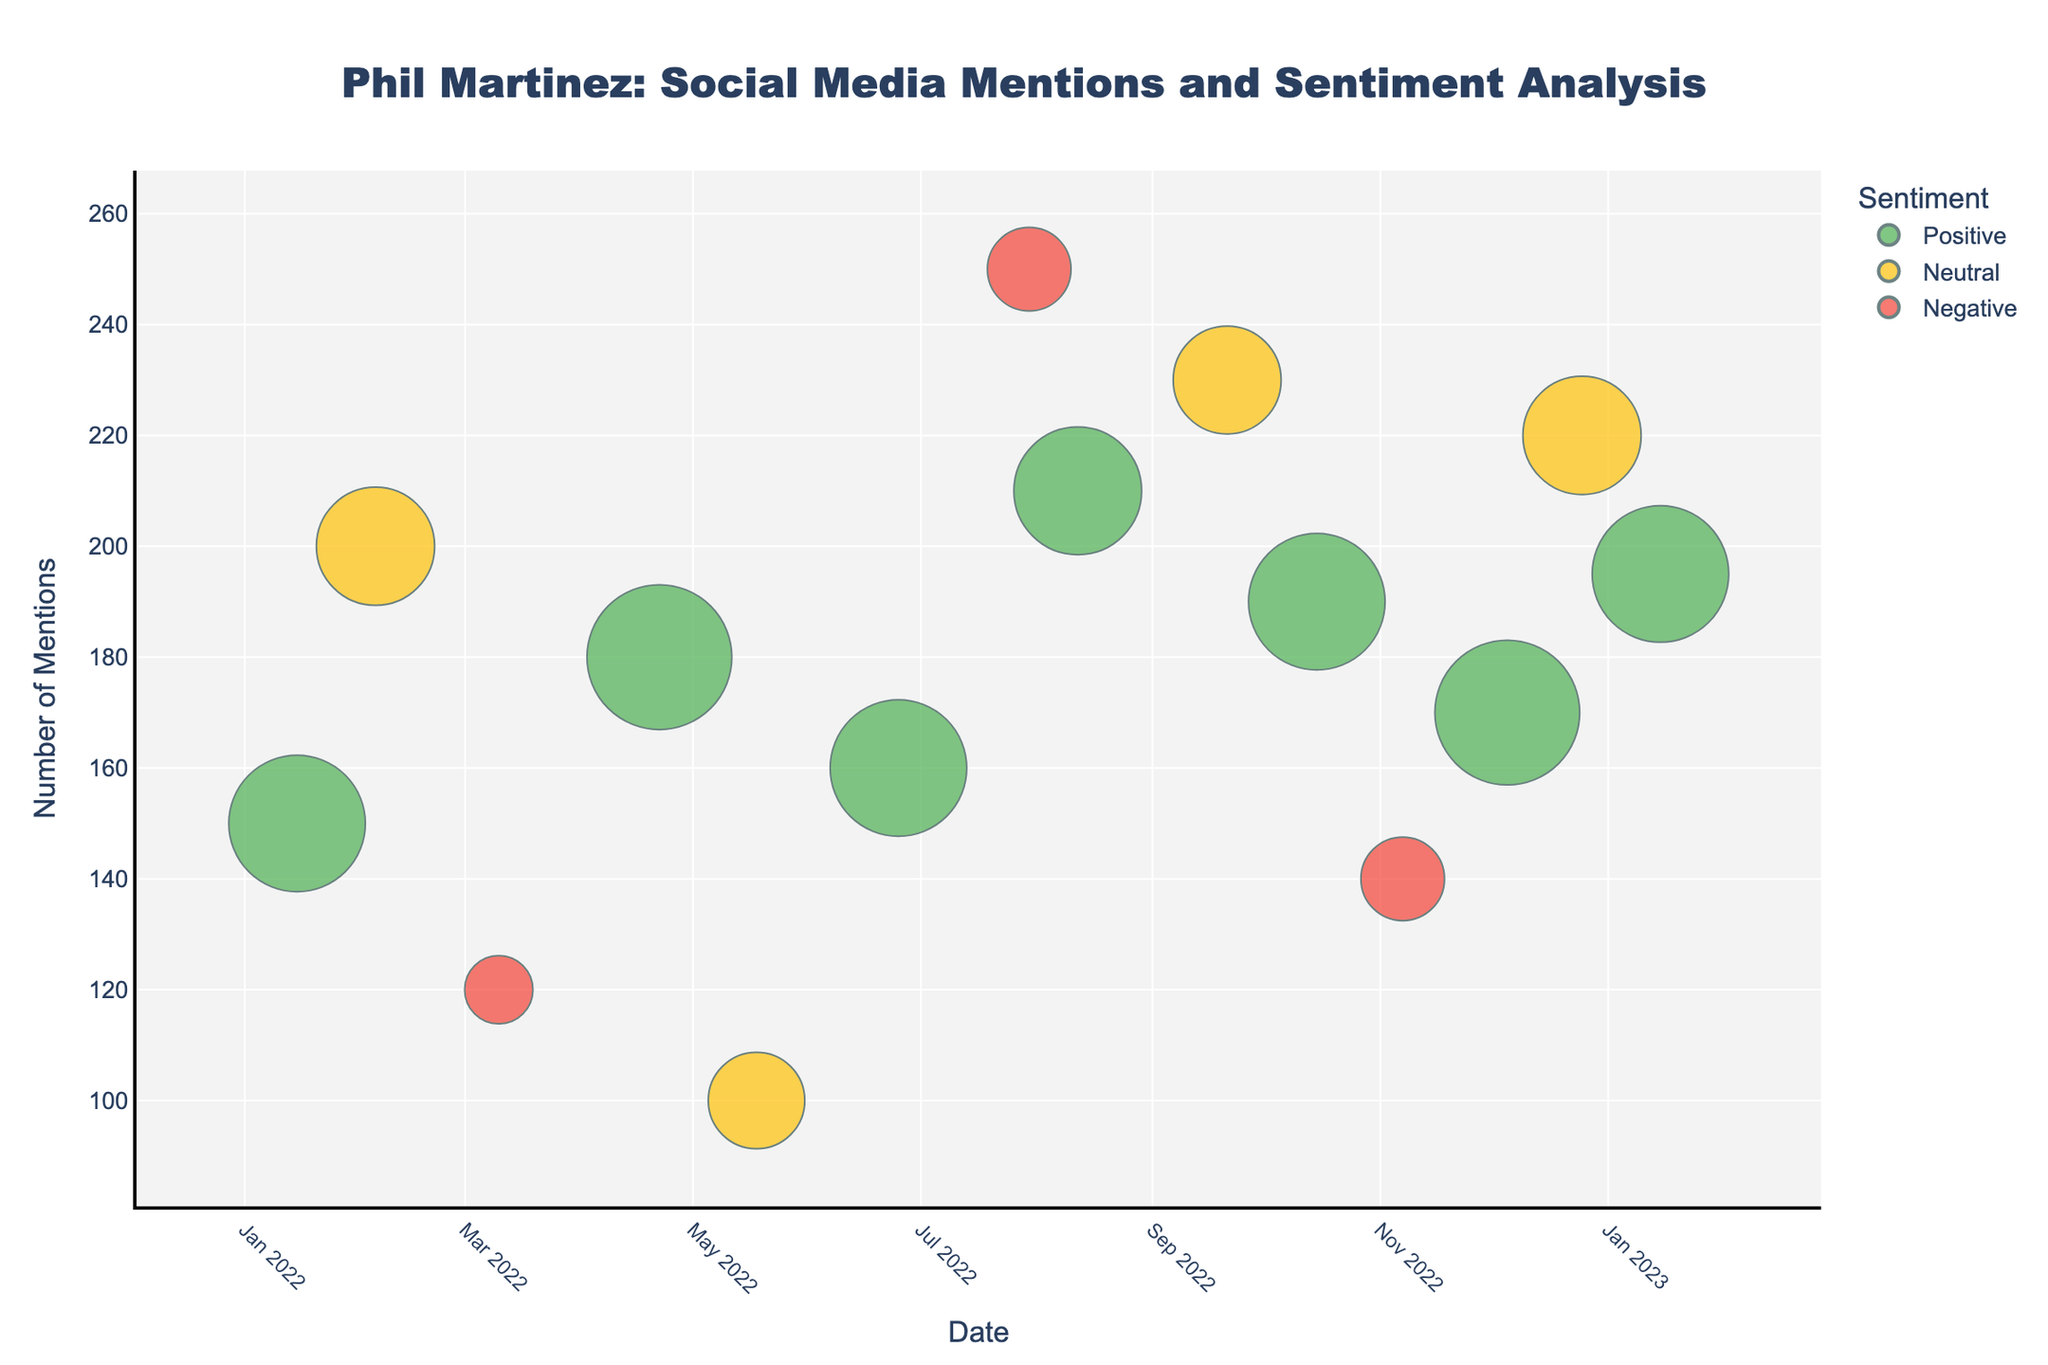What is the title of the figure? The title of the figure is usually displayed at the top and is meant to provide viewers with a summary of what the chart represents. Based on this, look at the top center of the figure for the main title.
Answer: Phil Martinez: Social Media Mentions and Sentiment Analysis How many mentions were there on Twitter in January 2023? To find the mentions for Twitter in January 2023, locate the relevant date on the x-axis, check the platform (Twitter), and then refer to the y-axis for the mentions. There is one data point on 2023-01-15 for Twitter.
Answer: 195 Which platform had the highest sentiment score and how many mentions did it get? The highest sentiment score, Positive, can be identified by looking at the chart legend and finding the corresponding color on the chart. Next, locate the bubble with the highest mentions of this color. Positive mentions peak on Facebook with a score around April 2022 and August 2022.
Answer: Instagram, 180 mentions Which month had the lowest number of mentions and what was the sentiment? Identify the smallest bubble on the y-axis which represents the number of mentions. Find the month and check the color to find the sentiment. The smallest number of mentions, around 100, was on Instagram in May 2022.
Answer: May 2022, Neutral Which sentiment had the highest frequency of mentions across all platforms? Tally the number of mentions for each sentiment type by observing the color corresponding to each sentiment across all platforms. Positive sentiment appears most frequently: Twitter, Instagram, and Facebook
Answer: Positive On which platform and month did Phil Martinez receive the highest popularity score, and what was the sentiment? Identify the largest bubble corresponding to the peak popularity score. Cross-check with the platform and month from data labels or hover info. The largest is on Instagram in April 2022, inferred as Positive sentiment.
Answer: Instagram, April 2022, Positive Which platform had the most neutral mentions and how many were there? Identify all the Neutral bubbles color for each platform and count or sum. Facebook has the largest number of neutral mentions observed in July 2022 (230).
Answer: Facebook, 230 Which two months had the same sentiment but different number of mentions on Facebook? Look for bubbles of the same sentiment color and platform; then compare mentions. In July 2022 (250 Negative) and December 2022 (220 Neutral).
Answer: July 2022 and December 2022, Negative 